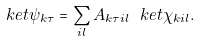Convert formula to latex. <formula><loc_0><loc_0><loc_500><loc_500>\ k e t { \psi _ { k \tau } } = \sum _ { i l } A _ { k \tau i l } \ k e t { \chi _ { k i l } } .</formula> 